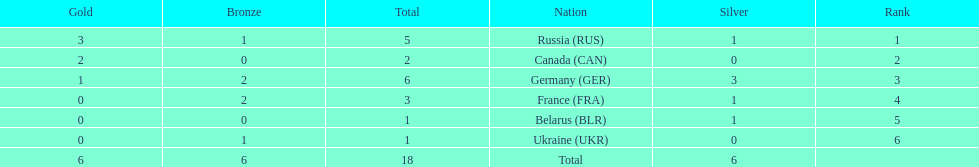How many silver medals did belarus win? 1. 